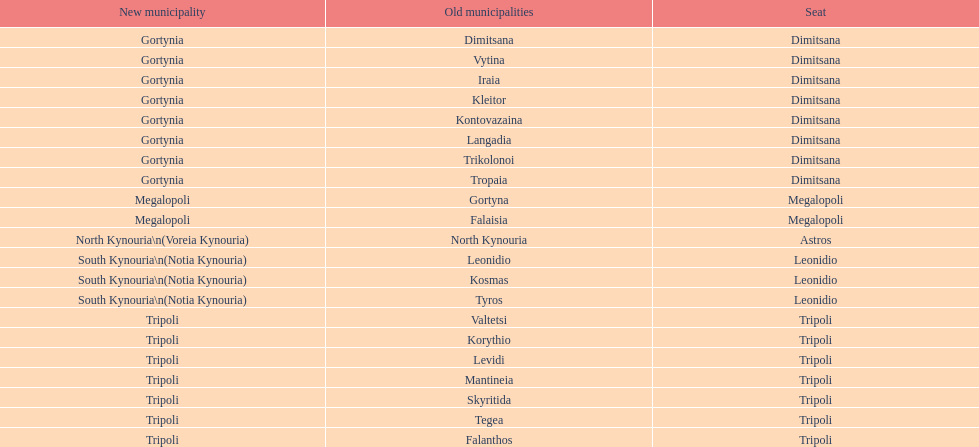How many old municipalities were in tripoli? 8. 